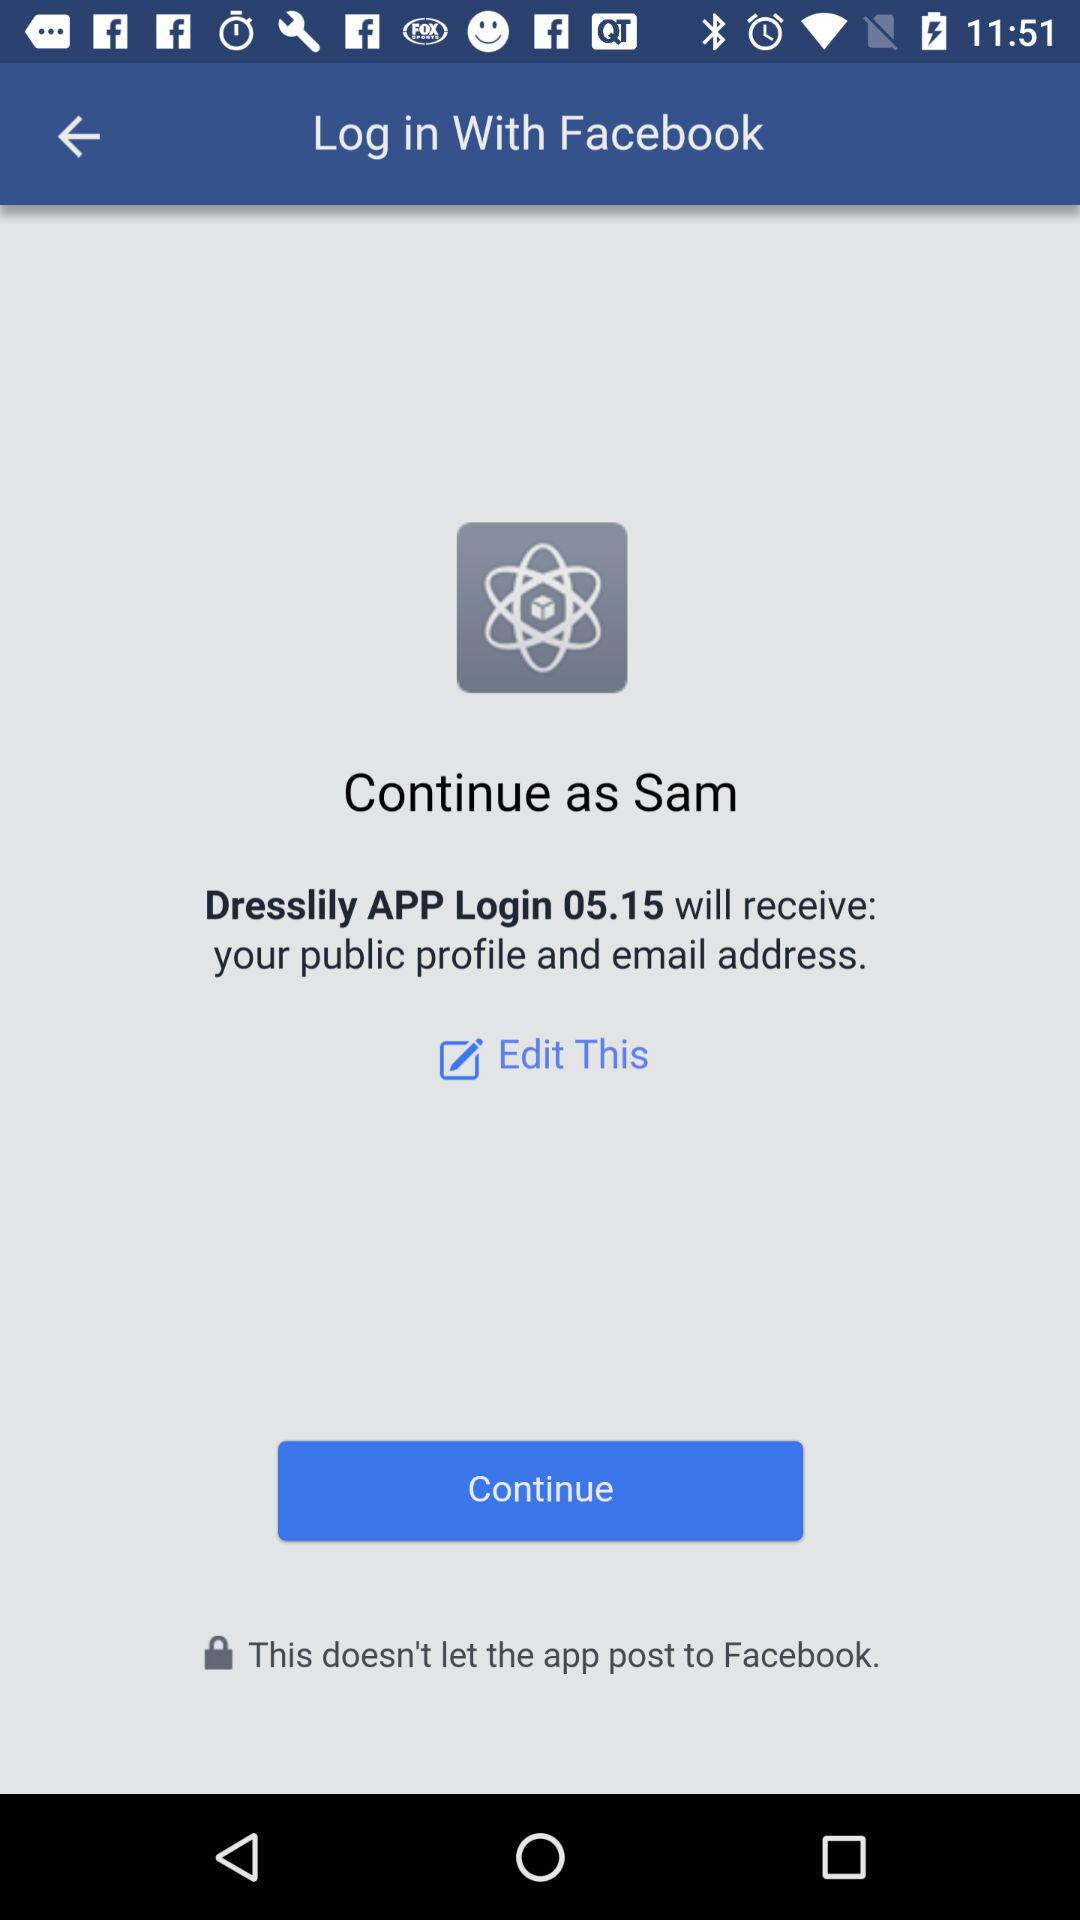What application will receive your public profile and email address? The application "Dresslily APP Login 05.15" will receive your public profile and email address. 